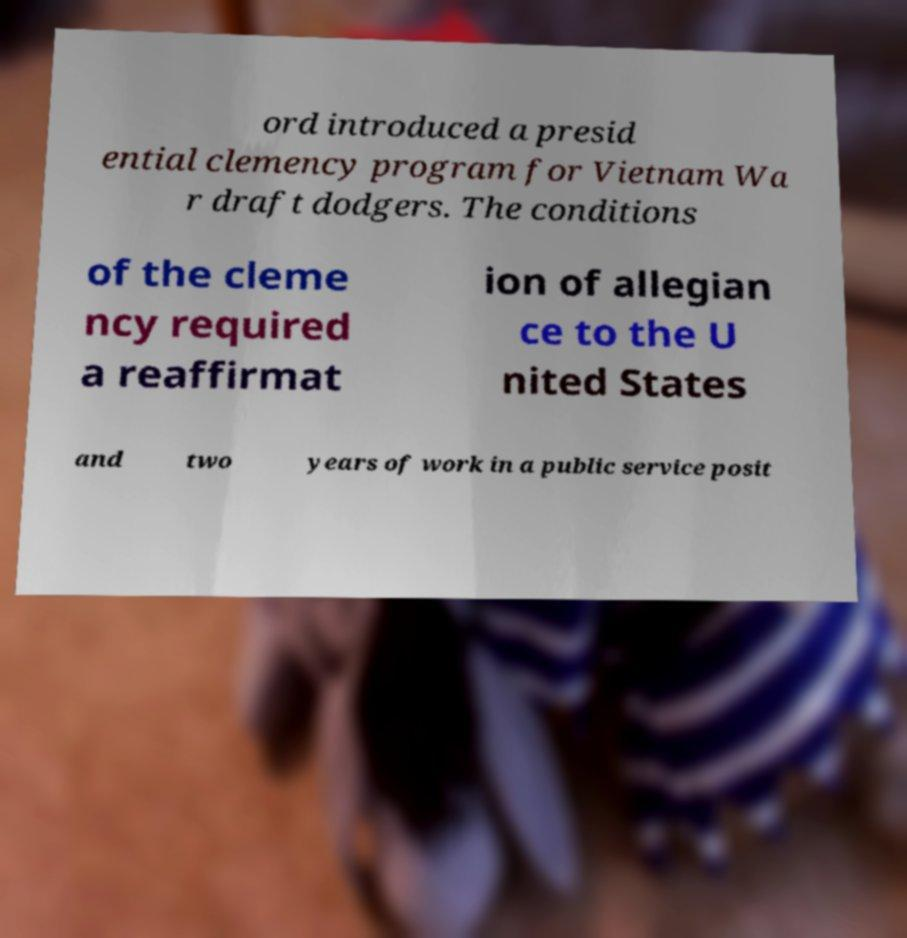Could you extract and type out the text from this image? ord introduced a presid ential clemency program for Vietnam Wa r draft dodgers. The conditions of the cleme ncy required a reaffirmat ion of allegian ce to the U nited States and two years of work in a public service posit 